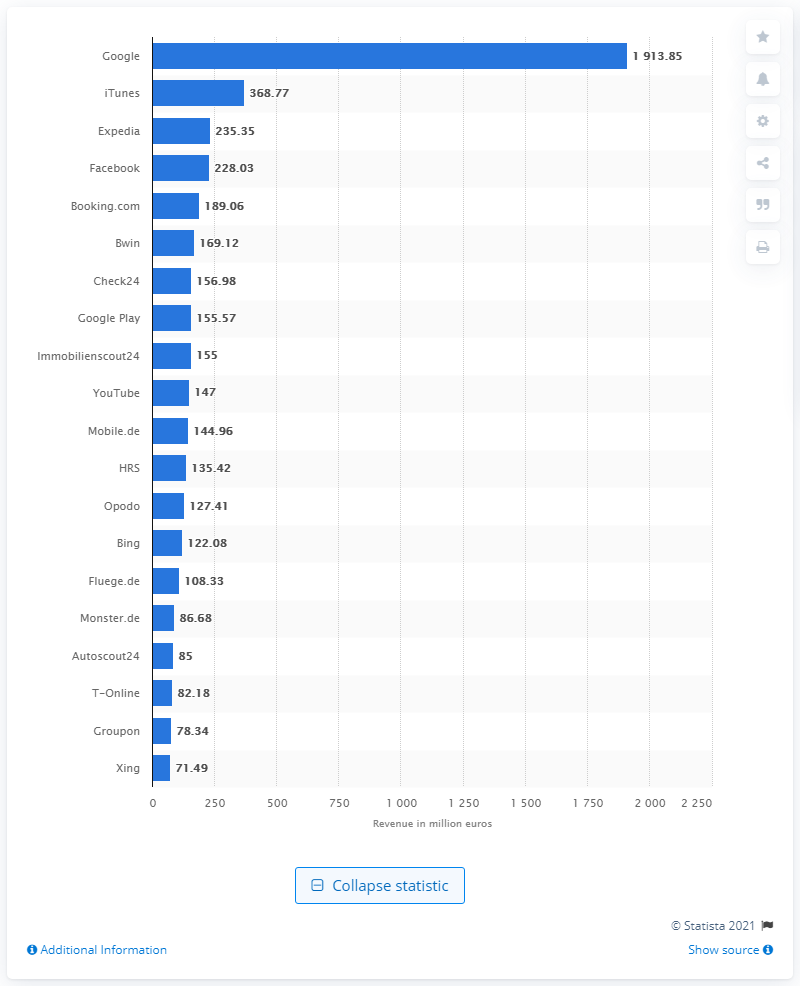Indicate a few pertinent items in this graphic. As of 2021, Google's annual revenue is approximately 191.385 billion dollars. 